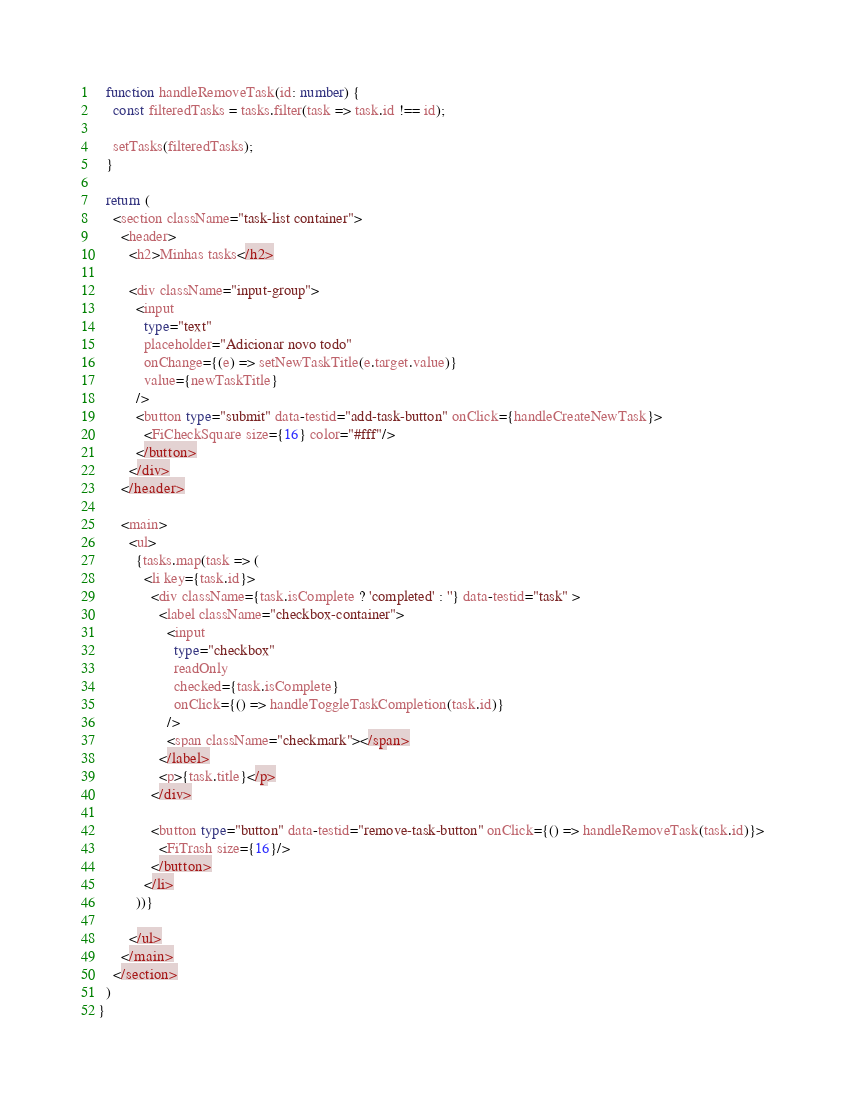<code> <loc_0><loc_0><loc_500><loc_500><_TypeScript_>  function handleRemoveTask(id: number) {
    const filteredTasks = tasks.filter(task => task.id !== id);

    setTasks(filteredTasks);
  }

  return (
    <section className="task-list container">
      <header>
        <h2>Minhas tasks</h2>

        <div className="input-group">
          <input 
            type="text" 
            placeholder="Adicionar novo todo" 
            onChange={(e) => setNewTaskTitle(e.target.value)}
            value={newTaskTitle}
          />
          <button type="submit" data-testid="add-task-button" onClick={handleCreateNewTask}>
            <FiCheckSquare size={16} color="#fff"/>
          </button>
        </div>
      </header>

      <main>
        <ul>
          {tasks.map(task => (
            <li key={task.id}>
              <div className={task.isComplete ? 'completed' : ''} data-testid="task" >
                <label className="checkbox-container">
                  <input 
                    type="checkbox"
                    readOnly
                    checked={task.isComplete}
                    onClick={() => handleToggleTaskCompletion(task.id)}
                  />
                  <span className="checkmark"></span>
                </label>
                <p>{task.title}</p>
              </div>

              <button type="button" data-testid="remove-task-button" onClick={() => handleRemoveTask(task.id)}>
                <FiTrash size={16}/>
              </button>
            </li>
          ))}
          
        </ul>
      </main>
    </section>
  )
}</code> 